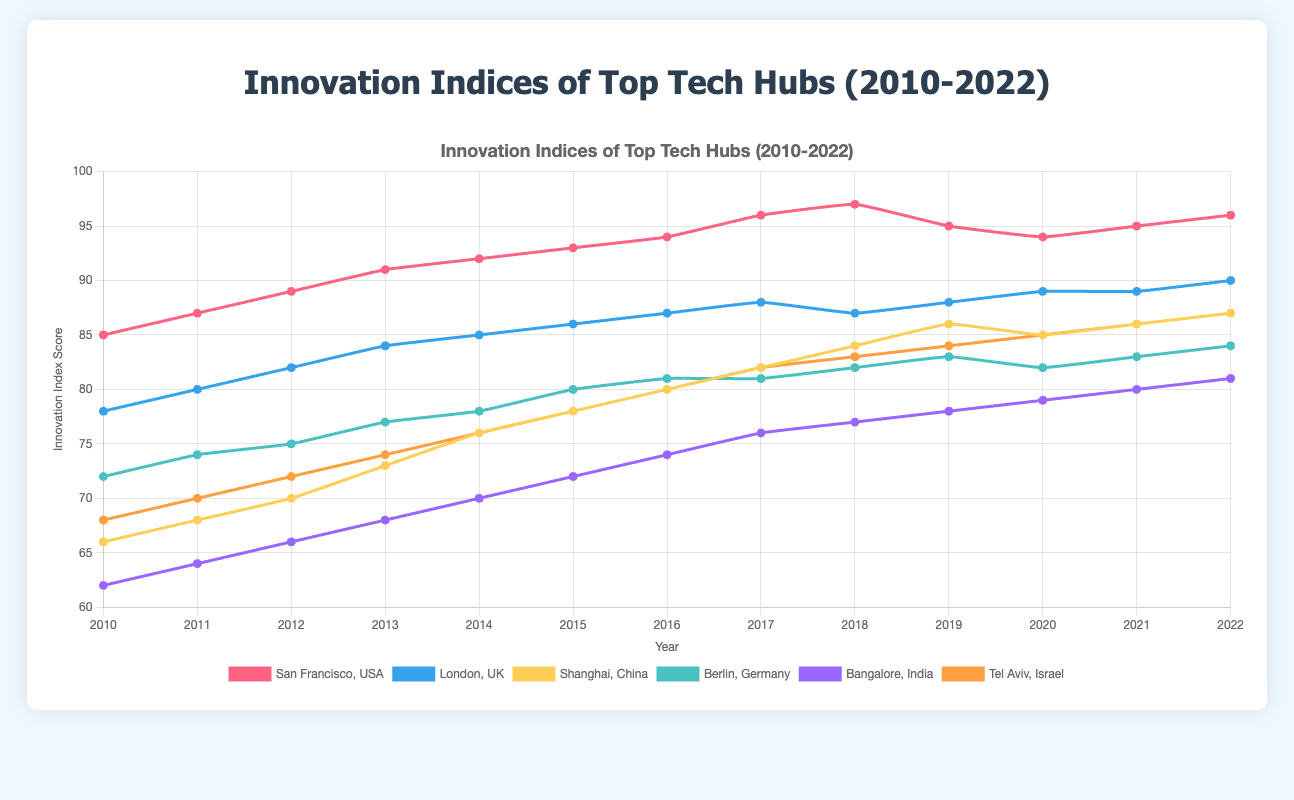What was the highest innovation index score for San Francisco, and in which year did it occur? The highest score for San Francisco can be found by examining the plot or the data points; it occurs in 2018 with a score of 97.
Answer: 2018 How did the innovation index scores for London change from 2010 to 2022? To determine the change, look at the scores for London in 2010 and 2022. The score changed from 78 in 2010 to 90 in 2022. Thus, the score increased by 12 points.
Answer: Increased by 12 points Which tech hub had the lowest innovation index score in 2010, and what was the score? The lowest score in 2010 can be found among the cities listed in the plot. Bangalore had the lowest score with 62.
Answer: Bangalore, 62 What is the average innovation index score for Berlin from 2010 to 2022? To calculate the average, sum all the scores for Berlin and then divide by the number of years (13). The scores are [72, 74, 75, 77, 78, 80, 81, 81, 82, 83, 82, 83, 84]. The sum is 952 and the average is 952/13 ≈ 73.23.
Answer: 73.23 Between 2018 and 2022, which city saw the biggest increase in their innovation index score, and what was the increase? Calculate the difference in scores between 2018 and 2022 for each city. Tel Aviv saw an increase from 83 to 87, which is a 4-point increase. The other cities had smaller or no increases over this period.
Answer: Tel Aviv, 4 points Compare the innovation index scores for San Francisco in 2019 and 2020. Which year had a higher score? By examining the scores for San Francisco, 2019 had a score of 95 and 2020 had a score of 94. Therefore, 2019 had a higher score.
Answer: 2019 Which tech hub had a consistent increase in their innovation index score from 2010 to 2022? Look for cities whose scores increase steadily every year. Bangalore's scores increase each year from 2010 (62) to 2022 (81).
Answer: Bangalore What was the trend for Shanghai’s innovation index score between 2015 and 2020? Review Shanghai’s scores from 2015 (78) to 2020 (85). There is a consistent upward trend, showing an increase each year: 78, 80, 82, 84, 86, 85.
Answer: Upward trend How did the innovation index for Tel Aviv in 2013 compare to the index in 2016? Compare the scores: Tel Aviv had a score of 74 in 2013 and 80 in 2016. Thus, the score increased by 6 points.
Answer: Increased by 6 points 